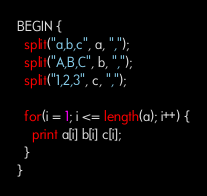<code> <loc_0><loc_0><loc_500><loc_500><_Awk_>BEGIN {
  split("a,b,c", a, ",");
  split("A,B,C", b, ",");
  split("1,2,3", c, ",");

  for(i = 1; i <= length(a); i++) {
    print a[i] b[i] c[i];
  }
}
</code> 